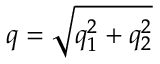<formula> <loc_0><loc_0><loc_500><loc_500>q = \sqrt { q _ { 1 } ^ { 2 } + q _ { 2 } ^ { 2 } }</formula> 